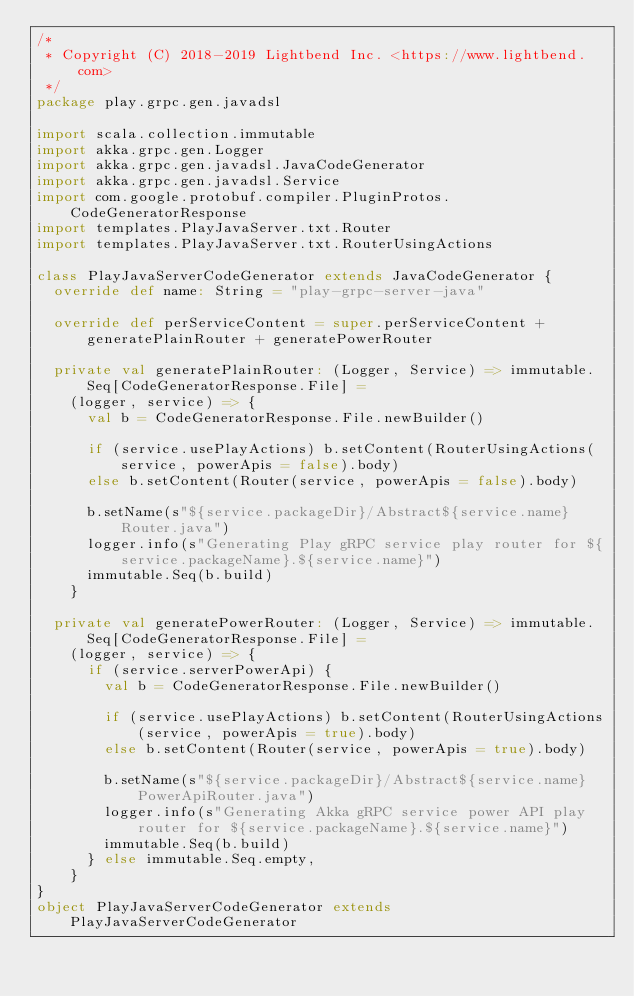Convert code to text. <code><loc_0><loc_0><loc_500><loc_500><_Scala_>/*
 * Copyright (C) 2018-2019 Lightbend Inc. <https://www.lightbend.com>
 */
package play.grpc.gen.javadsl

import scala.collection.immutable
import akka.grpc.gen.Logger
import akka.grpc.gen.javadsl.JavaCodeGenerator
import akka.grpc.gen.javadsl.Service
import com.google.protobuf.compiler.PluginProtos.CodeGeneratorResponse
import templates.PlayJavaServer.txt.Router
import templates.PlayJavaServer.txt.RouterUsingActions

class PlayJavaServerCodeGenerator extends JavaCodeGenerator {
  override def name: String = "play-grpc-server-java"

  override def perServiceContent = super.perServiceContent + generatePlainRouter + generatePowerRouter

  private val generatePlainRouter: (Logger, Service) => immutable.Seq[CodeGeneratorResponse.File] =
    (logger, service) => {
      val b = CodeGeneratorResponse.File.newBuilder()

      if (service.usePlayActions) b.setContent(RouterUsingActions(service, powerApis = false).body)
      else b.setContent(Router(service, powerApis = false).body)

      b.setName(s"${service.packageDir}/Abstract${service.name}Router.java")
      logger.info(s"Generating Play gRPC service play router for ${service.packageName}.${service.name}")
      immutable.Seq(b.build)
    }

  private val generatePowerRouter: (Logger, Service) => immutable.Seq[CodeGeneratorResponse.File] =
    (logger, service) => {
      if (service.serverPowerApi) {
        val b = CodeGeneratorResponse.File.newBuilder()

        if (service.usePlayActions) b.setContent(RouterUsingActions(service, powerApis = true).body)
        else b.setContent(Router(service, powerApis = true).body)

        b.setName(s"${service.packageDir}/Abstract${service.name}PowerApiRouter.java")
        logger.info(s"Generating Akka gRPC service power API play router for ${service.packageName}.${service.name}")
        immutable.Seq(b.build)
      } else immutable.Seq.empty,
    }
}
object PlayJavaServerCodeGenerator extends PlayJavaServerCodeGenerator
</code> 